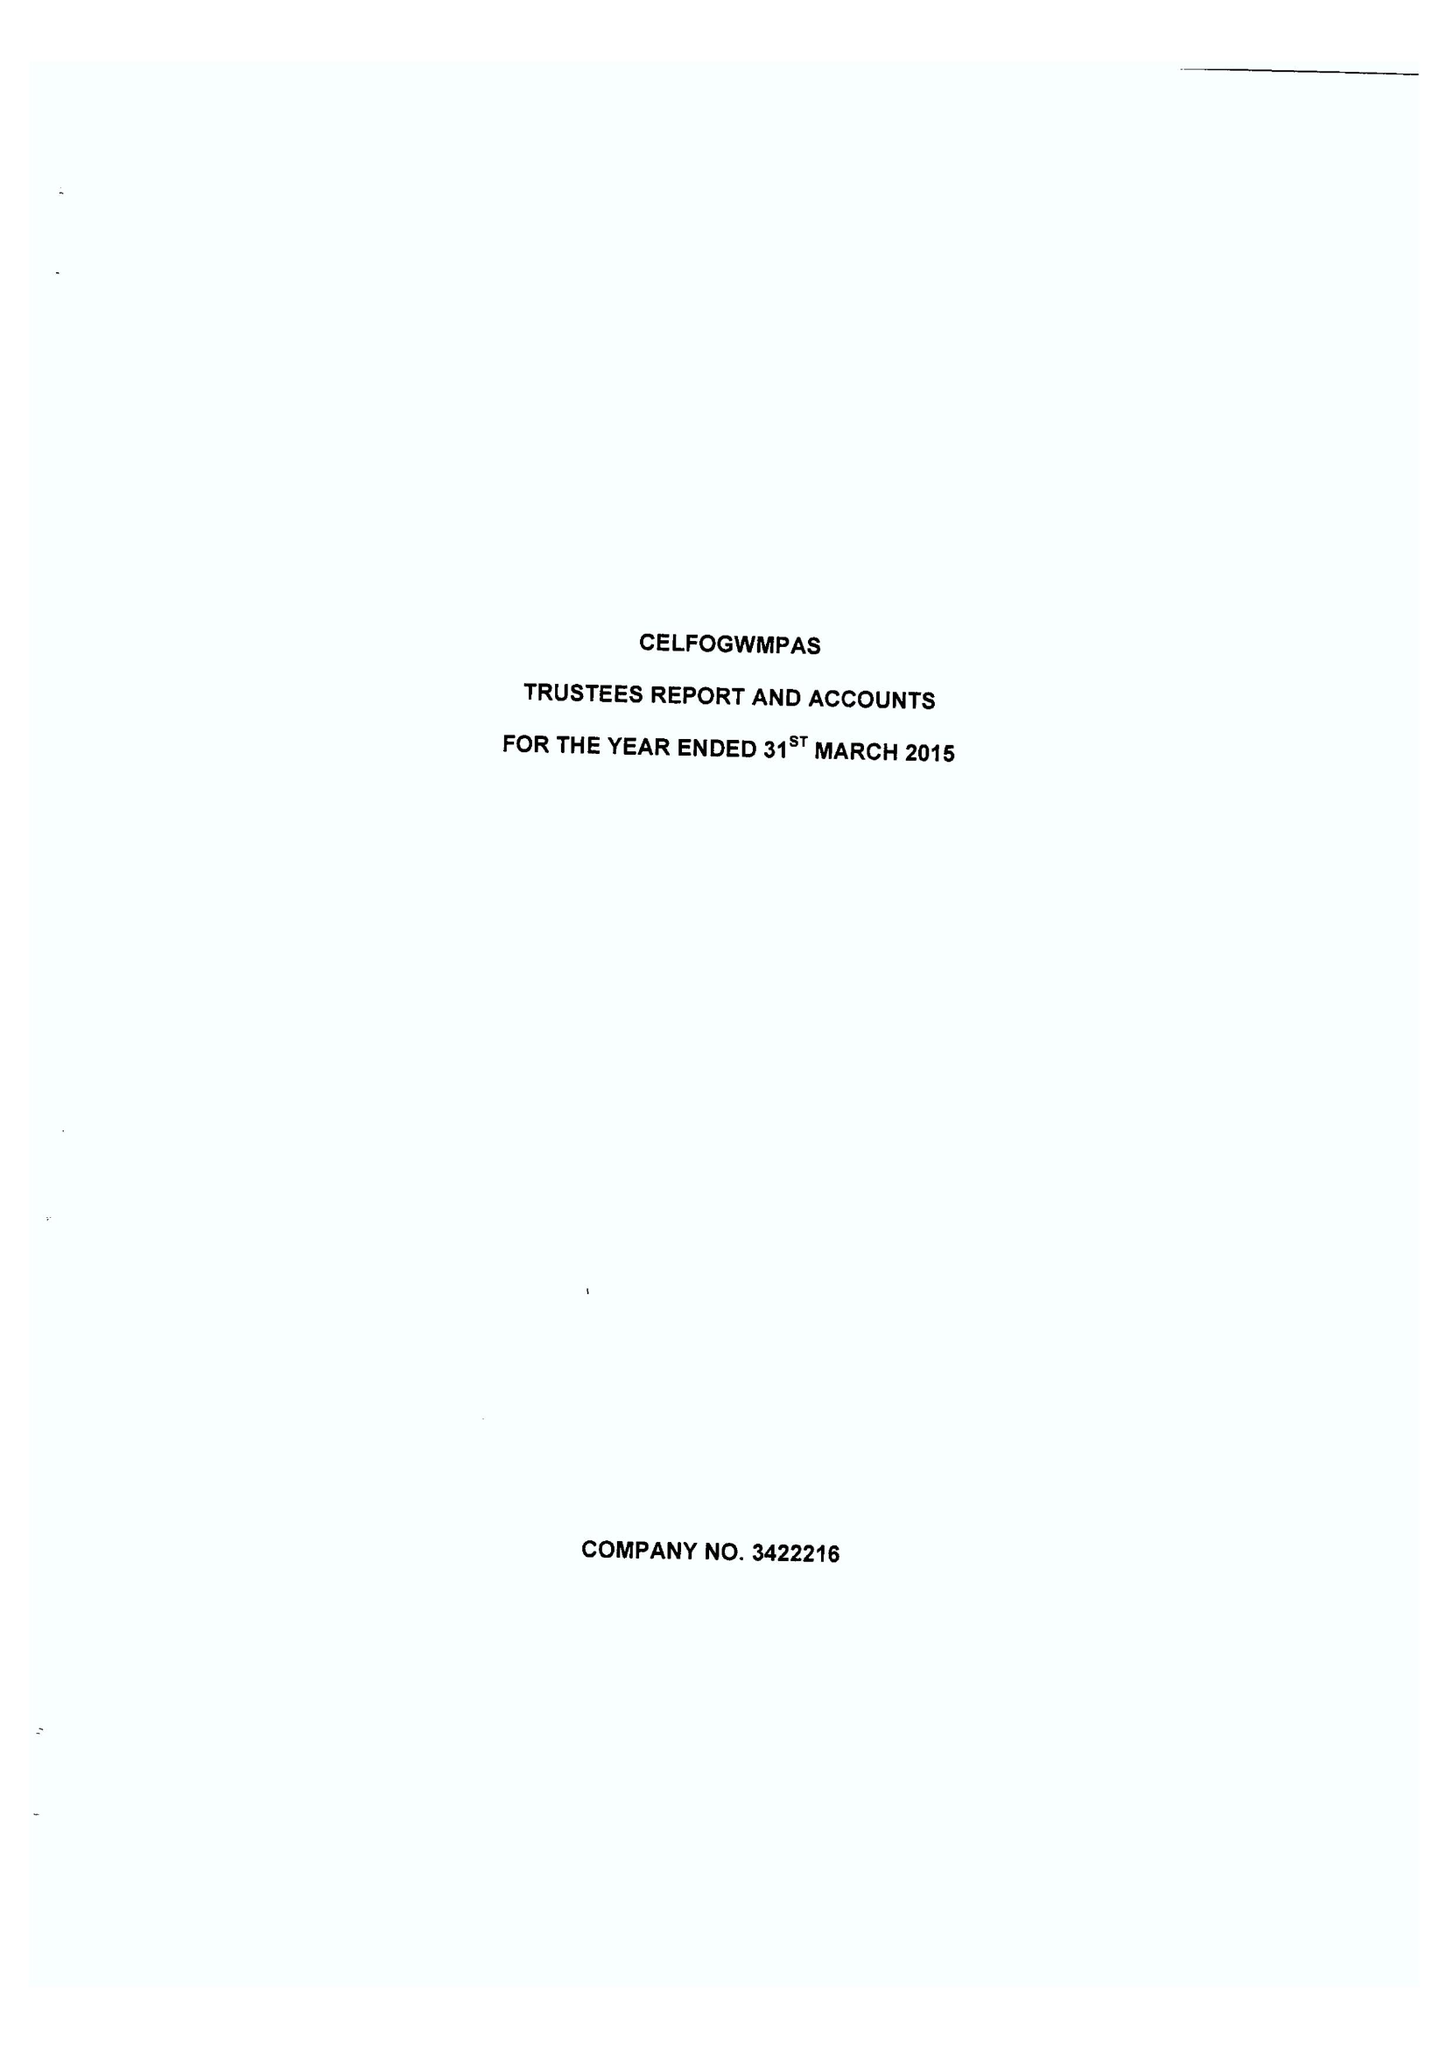What is the value for the charity_number?
Answer the question using a single word or phrase. 1073029 